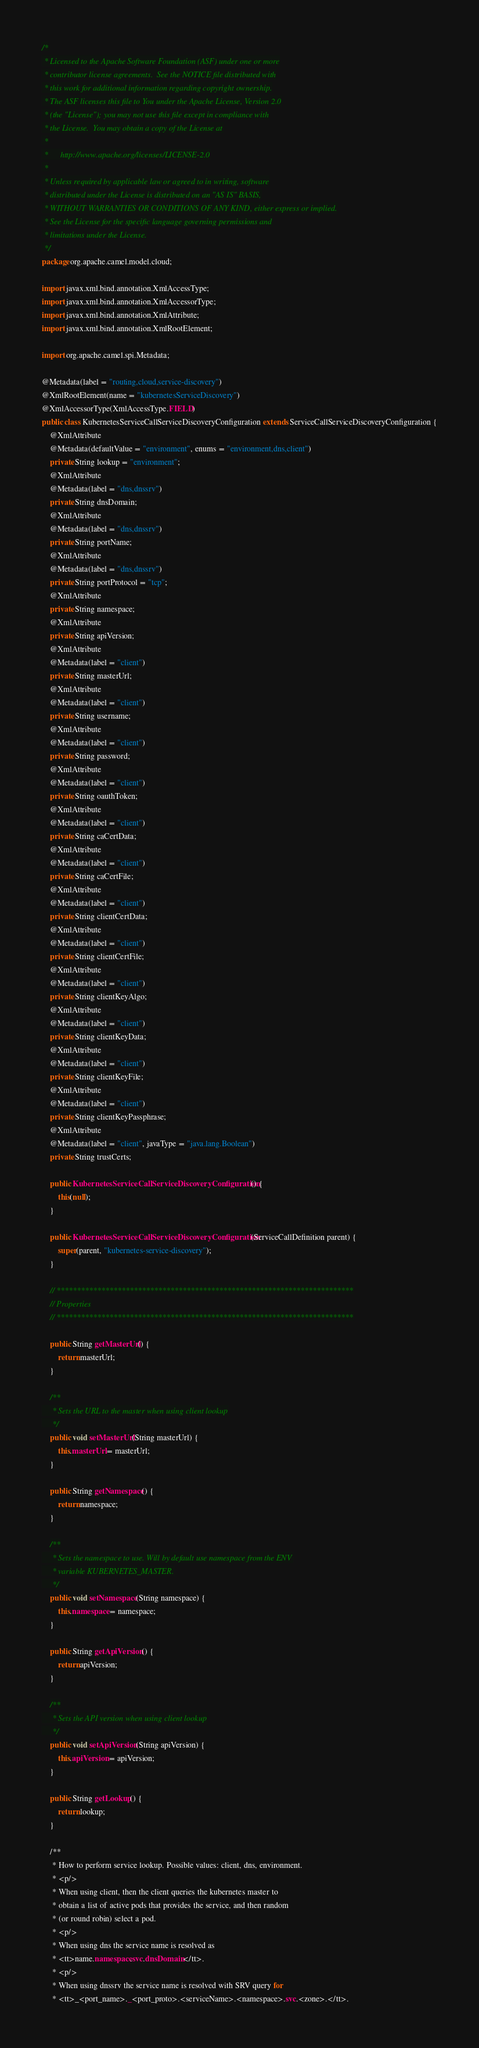<code> <loc_0><loc_0><loc_500><loc_500><_Java_>/*
 * Licensed to the Apache Software Foundation (ASF) under one or more
 * contributor license agreements.  See the NOTICE file distributed with
 * this work for additional information regarding copyright ownership.
 * The ASF licenses this file to You under the Apache License, Version 2.0
 * (the "License"); you may not use this file except in compliance with
 * the License.  You may obtain a copy of the License at
 *
 *      http://www.apache.org/licenses/LICENSE-2.0
 *
 * Unless required by applicable law or agreed to in writing, software
 * distributed under the License is distributed on an "AS IS" BASIS,
 * WITHOUT WARRANTIES OR CONDITIONS OF ANY KIND, either express or implied.
 * See the License for the specific language governing permissions and
 * limitations under the License.
 */
package org.apache.camel.model.cloud;

import javax.xml.bind.annotation.XmlAccessType;
import javax.xml.bind.annotation.XmlAccessorType;
import javax.xml.bind.annotation.XmlAttribute;
import javax.xml.bind.annotation.XmlRootElement;

import org.apache.camel.spi.Metadata;

@Metadata(label = "routing,cloud,service-discovery")
@XmlRootElement(name = "kubernetesServiceDiscovery")
@XmlAccessorType(XmlAccessType.FIELD)
public class KubernetesServiceCallServiceDiscoveryConfiguration extends ServiceCallServiceDiscoveryConfiguration {
    @XmlAttribute
    @Metadata(defaultValue = "environment", enums = "environment,dns,client")
    private String lookup = "environment";
    @XmlAttribute
    @Metadata(label = "dns,dnssrv")
    private String dnsDomain;
    @XmlAttribute
    @Metadata(label = "dns,dnssrv")
    private String portName;
    @XmlAttribute
    @Metadata(label = "dns,dnssrv")
    private String portProtocol = "tcp";
    @XmlAttribute
    private String namespace;
    @XmlAttribute
    private String apiVersion;
    @XmlAttribute
    @Metadata(label = "client")
    private String masterUrl;
    @XmlAttribute
    @Metadata(label = "client")
    private String username;
    @XmlAttribute
    @Metadata(label = "client")
    private String password;
    @XmlAttribute
    @Metadata(label = "client")
    private String oauthToken;
    @XmlAttribute
    @Metadata(label = "client")
    private String caCertData;
    @XmlAttribute
    @Metadata(label = "client")
    private String caCertFile;
    @XmlAttribute
    @Metadata(label = "client")
    private String clientCertData;
    @XmlAttribute
    @Metadata(label = "client")
    private String clientCertFile;
    @XmlAttribute
    @Metadata(label = "client")
    private String clientKeyAlgo;
    @XmlAttribute
    @Metadata(label = "client")
    private String clientKeyData;
    @XmlAttribute
    @Metadata(label = "client")
    private String clientKeyFile;
    @XmlAttribute
    @Metadata(label = "client")
    private String clientKeyPassphrase;
    @XmlAttribute
    @Metadata(label = "client", javaType = "java.lang.Boolean")
    private String trustCerts;

    public KubernetesServiceCallServiceDiscoveryConfiguration() {
        this(null);
    }

    public KubernetesServiceCallServiceDiscoveryConfiguration(ServiceCallDefinition parent) {
        super(parent, "kubernetes-service-discovery");
    }

    // *************************************************************************
    // Properties
    // *************************************************************************

    public String getMasterUrl() {
        return masterUrl;
    }

    /**
     * Sets the URL to the master when using client lookup
     */
    public void setMasterUrl(String masterUrl) {
        this.masterUrl = masterUrl;
    }

    public String getNamespace() {
        return namespace;
    }

    /**
     * Sets the namespace to use. Will by default use namespace from the ENV
     * variable KUBERNETES_MASTER.
     */
    public void setNamespace(String namespace) {
        this.namespace = namespace;
    }

    public String getApiVersion() {
        return apiVersion;
    }

    /**
     * Sets the API version when using client lookup
     */
    public void setApiVersion(String apiVersion) {
        this.apiVersion = apiVersion;
    }

    public String getLookup() {
        return lookup;
    }

    /**
     * How to perform service lookup. Possible values: client, dns, environment.
     * <p/>
     * When using client, then the client queries the kubernetes master to
     * obtain a list of active pods that provides the service, and then random
     * (or round robin) select a pod.
     * <p/>
     * When using dns the service name is resolved as
     * <tt>name.namespace.svc.dnsDomain</tt>.
     * <p/>
     * When using dnssrv the service name is resolved with SRV query for
     * <tt>_<port_name>._<port_proto>.<serviceName>.<namespace>.svc.<zone>.</tt>.</code> 